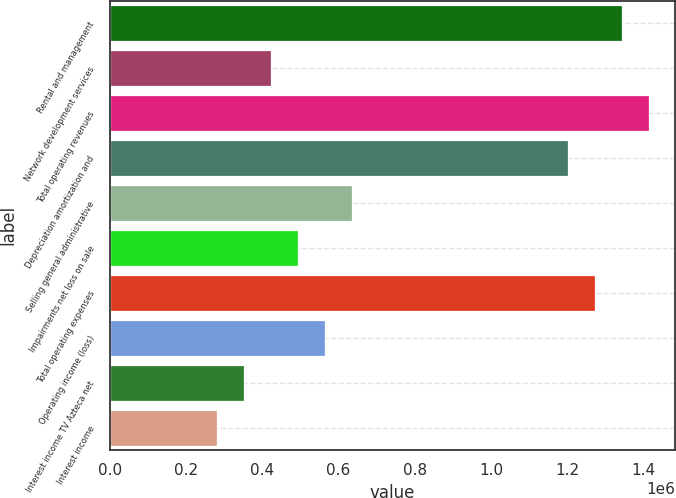Convert chart to OTSL. <chart><loc_0><loc_0><loc_500><loc_500><bar_chart><fcel>Rental and management<fcel>Network development services<fcel>Total operating revenues<fcel>Depreciation amortization and<fcel>Selling general administrative<fcel>Impairments net loss on sale<fcel>Total operating expenses<fcel>Operating income (loss)<fcel>Interest income TV Azteca net<fcel>Interest income<nl><fcel>1.34265e+06<fcel>423996<fcel>1.41332e+06<fcel>1.20132e+06<fcel>635994<fcel>494662<fcel>1.27199e+06<fcel>565328<fcel>353331<fcel>282665<nl></chart> 